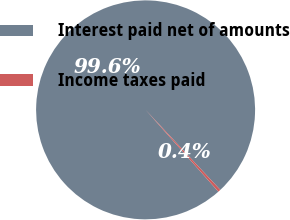Convert chart to OTSL. <chart><loc_0><loc_0><loc_500><loc_500><pie_chart><fcel>Interest paid net of amounts<fcel>Income taxes paid<nl><fcel>99.62%<fcel>0.38%<nl></chart> 